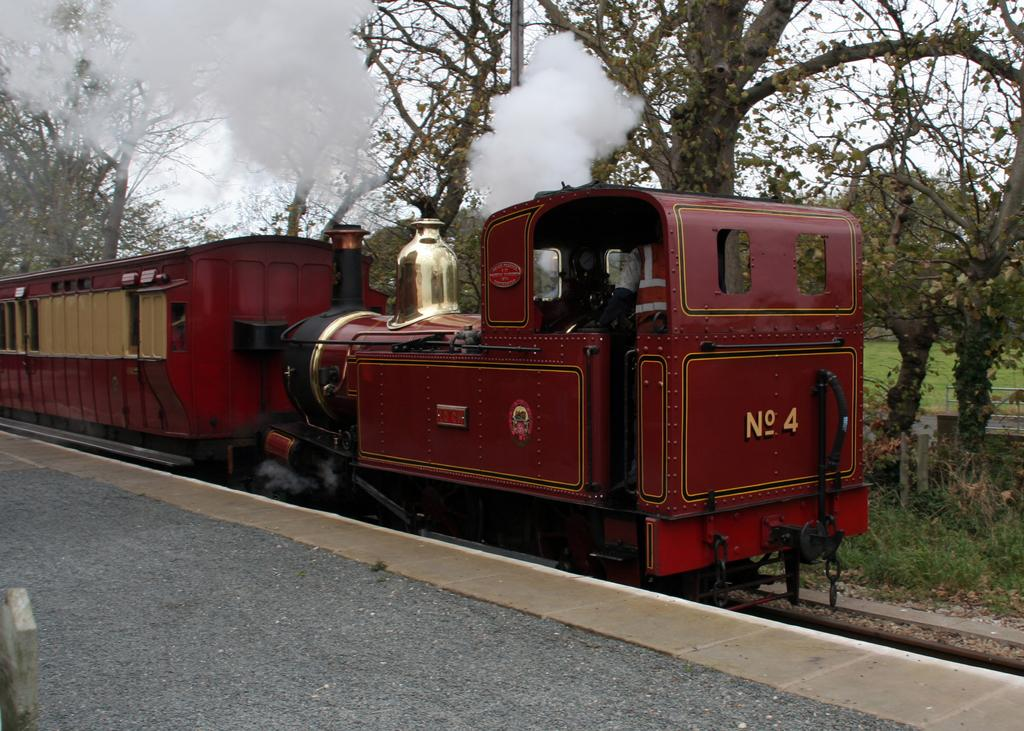What is the main subject of the image? The main subject of the image is a train. What is the train situated on? The train is on tracks. What can be seen in the background or near the train? There are trees beside the train. What type of book can be seen in the library section of the train? There is no library or book present in the image; it only features a train on tracks with trees beside it. 